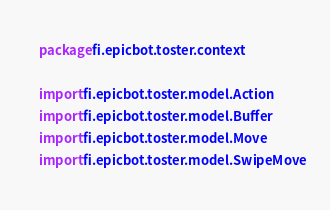<code> <loc_0><loc_0><loc_500><loc_500><_Kotlin_>package fi.epicbot.toster.context

import fi.epicbot.toster.model.Action
import fi.epicbot.toster.model.Buffer
import fi.epicbot.toster.model.Move
import fi.epicbot.toster.model.SwipeMove</code> 